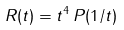<formula> <loc_0><loc_0><loc_500><loc_500>R ( t ) = t ^ { 4 } \, P ( 1 / t )</formula> 